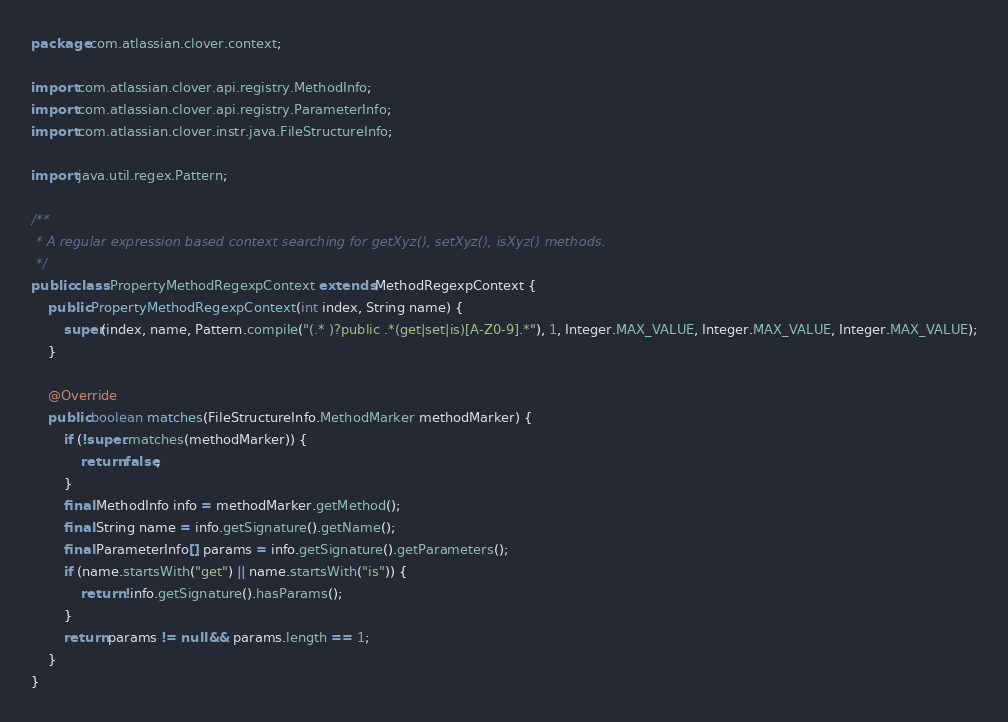Convert code to text. <code><loc_0><loc_0><loc_500><loc_500><_Java_>package com.atlassian.clover.context;

import com.atlassian.clover.api.registry.MethodInfo;
import com.atlassian.clover.api.registry.ParameterInfo;
import com.atlassian.clover.instr.java.FileStructureInfo;

import java.util.regex.Pattern;

/**
 * A regular expression based context searching for getXyz(), setXyz(), isXyz() methods.
 */
public class PropertyMethodRegexpContext extends MethodRegexpContext {
    public PropertyMethodRegexpContext(int index, String name) {
        super(index, name, Pattern.compile("(.* )?public .*(get|set|is)[A-Z0-9].*"), 1, Integer.MAX_VALUE, Integer.MAX_VALUE, Integer.MAX_VALUE);
    }

    @Override
    public boolean matches(FileStructureInfo.MethodMarker methodMarker) {
        if (!super.matches(methodMarker)) {
            return false;
        }
        final MethodInfo info = methodMarker.getMethod();
        final String name = info.getSignature().getName();
        final ParameterInfo[] params = info.getSignature().getParameters();
        if (name.startsWith("get") || name.startsWith("is")) {
            return !info.getSignature().hasParams();
        }
        return params != null && params.length == 1;
    }
}
</code> 